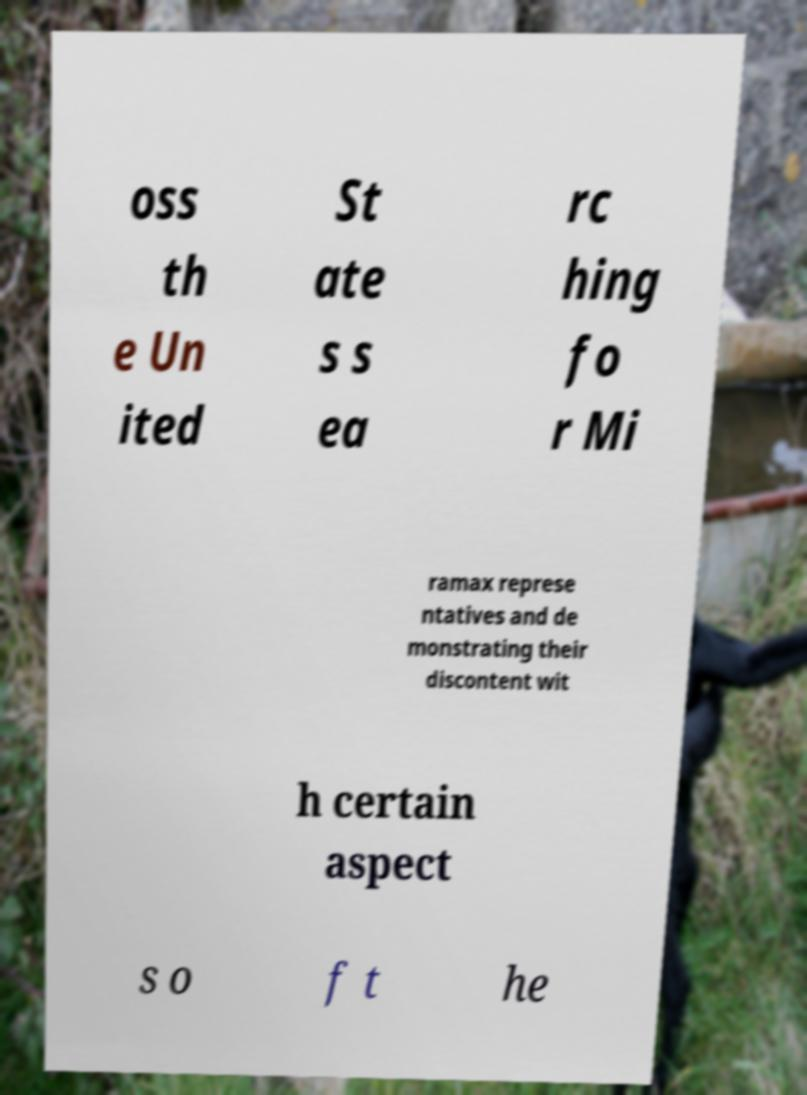Please identify and transcribe the text found in this image. oss th e Un ited St ate s s ea rc hing fo r Mi ramax represe ntatives and de monstrating their discontent wit h certain aspect s o f t he 